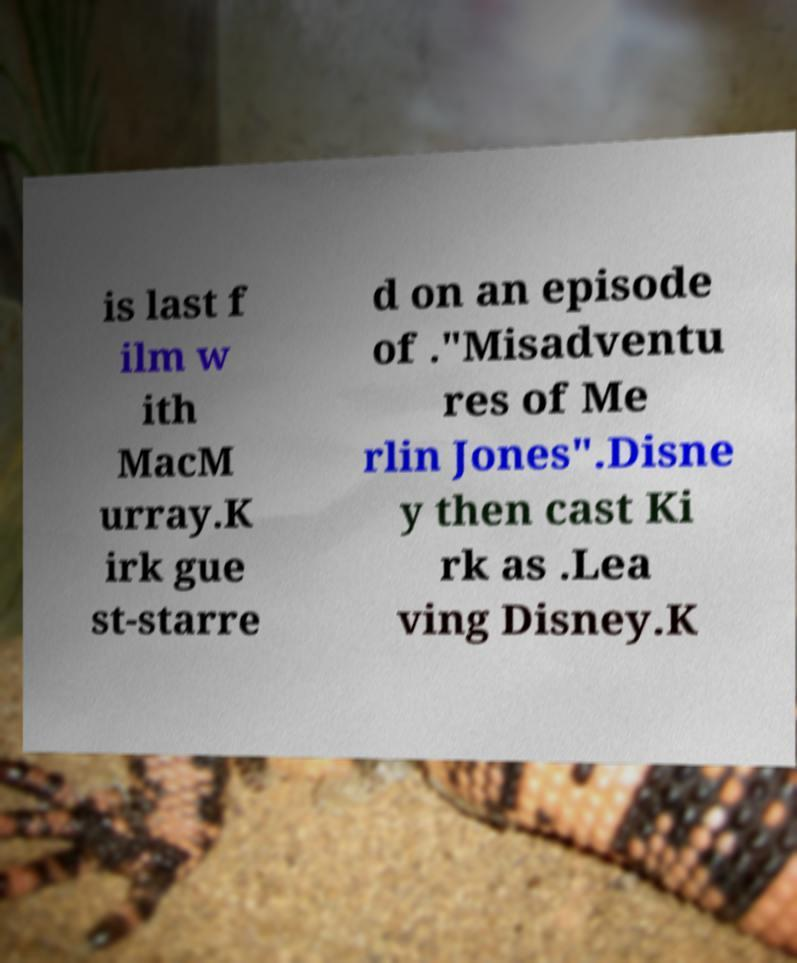For documentation purposes, I need the text within this image transcribed. Could you provide that? is last f ilm w ith MacM urray.K irk gue st-starre d on an episode of ."Misadventu res of Me rlin Jones".Disne y then cast Ki rk as .Lea ving Disney.K 